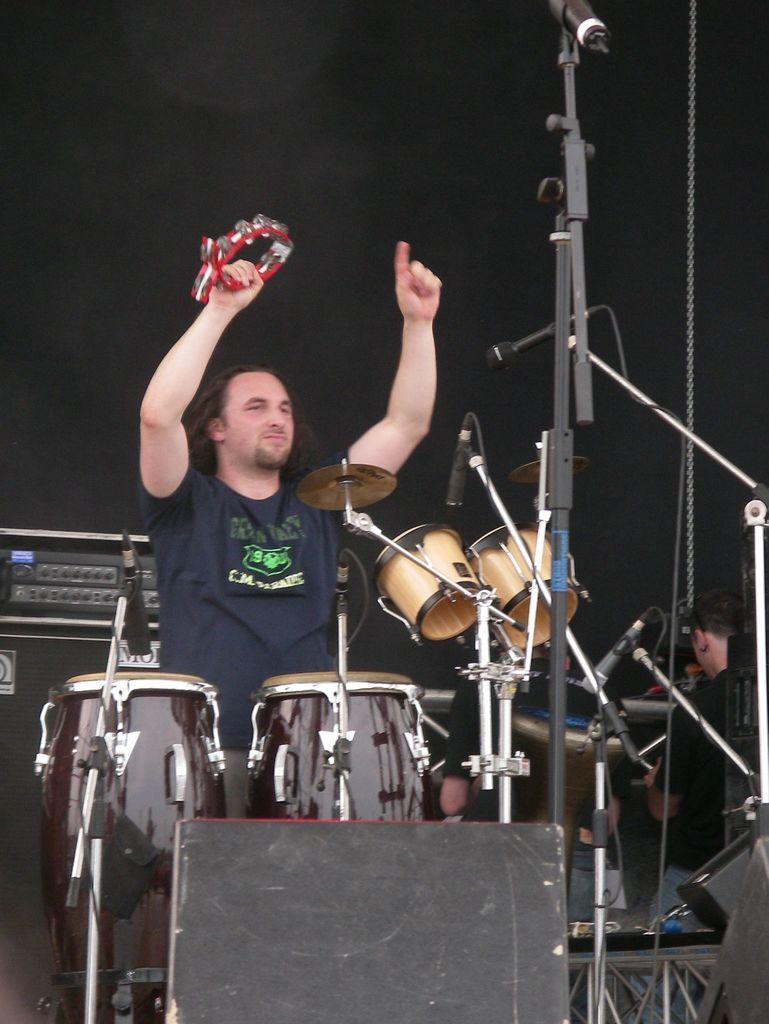What objects are present in the image related to music? There are musical instruments in the image. Is anyone interacting with the musical instruments? Yes, a person is playing the musical instruments. What device can be seen in the middle of the image? There is a microphone (mic) in the middle of the image. What type of steel is used to make the star-shaped heart in the image? There is no steel, star, or heart present in the image. 